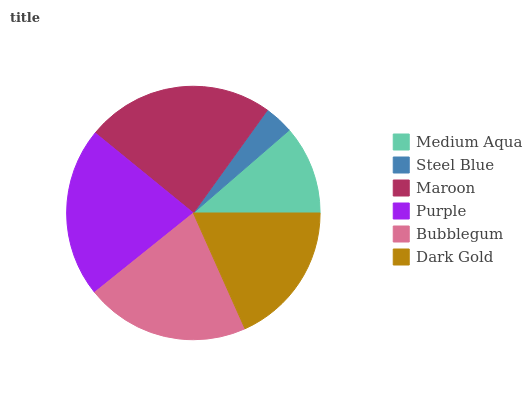Is Steel Blue the minimum?
Answer yes or no. Yes. Is Maroon the maximum?
Answer yes or no. Yes. Is Maroon the minimum?
Answer yes or no. No. Is Steel Blue the maximum?
Answer yes or no. No. Is Maroon greater than Steel Blue?
Answer yes or no. Yes. Is Steel Blue less than Maroon?
Answer yes or no. Yes. Is Steel Blue greater than Maroon?
Answer yes or no. No. Is Maroon less than Steel Blue?
Answer yes or no. No. Is Bubblegum the high median?
Answer yes or no. Yes. Is Dark Gold the low median?
Answer yes or no. Yes. Is Steel Blue the high median?
Answer yes or no. No. Is Bubblegum the low median?
Answer yes or no. No. 